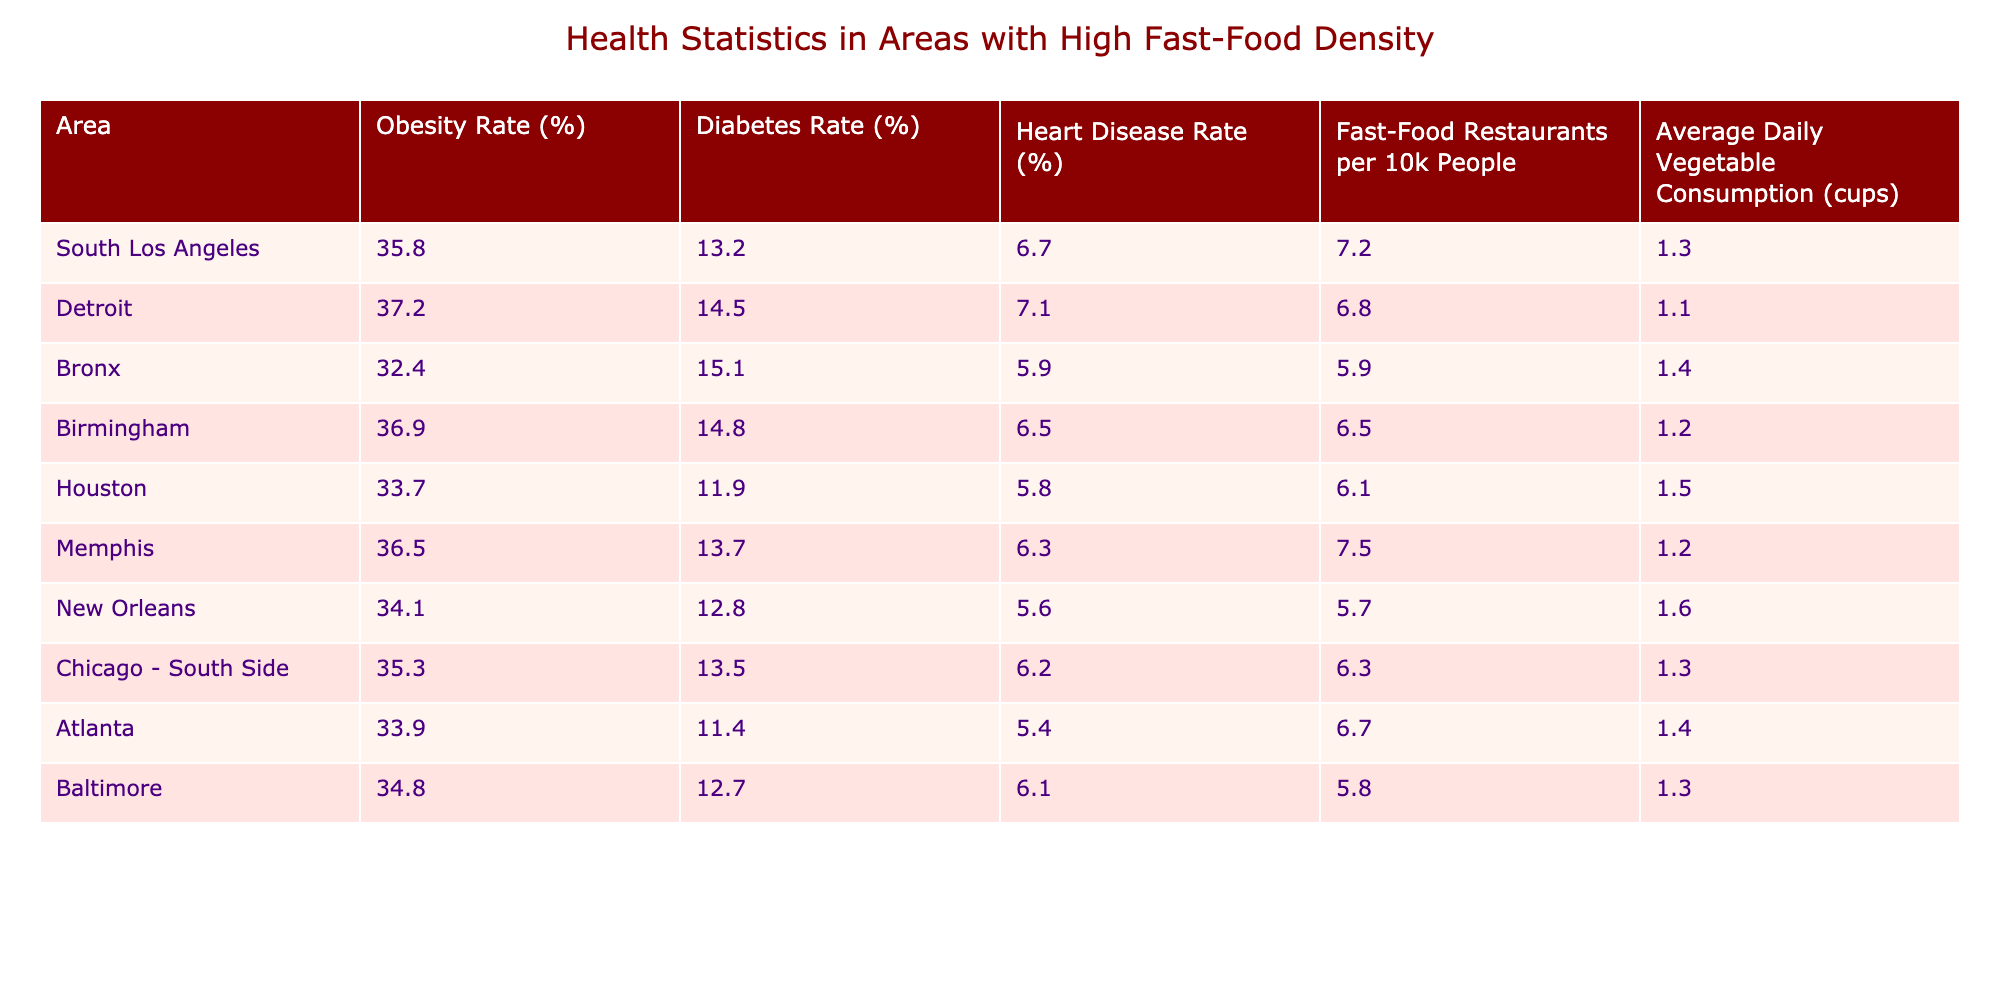What is the obesity rate in Detroit? The table lists Detroit's obesity rate directly under the "Obesity Rate (%)" column, which is 37.2%.
Answer: 37.2% Which area has the highest heart disease rate? By comparing the heart disease rates in each area from the "Heart Disease Rate (%)" column, Detroit has the highest rate at 7.1%.
Answer: Detroit What is the average daily vegetable consumption in New Orleans? The table shows the average daily vegetable consumption in New Orleans under the "Average Daily Vegetable Consumption (cups)" column, which is 1.6 cups.
Answer: 1.6 What is the total number of fast-food restaurants per 10,000 people in South Los Angeles and Chicago - South Side combined? The total is calculated by adding the fast-food restaurant densities: South Los Angeles (7.2) + Chicago - South Side (6.3) = 13.5.
Answer: 13.5 Is the average daily vegetable consumption higher in Houston compared to Detroit? Houston has an average of 1.5 cups, while Detroit has 1.1 cups; thus, the average in Houston is higher.
Answer: Yes Which area has a higher obesity rate: Birmingham or Memphis? Birmingham's obesity rate is 36.9%, while Memphis's is 36.5%. Therefore, Birmingham has a higher rate.
Answer: Birmingham What is the difference in diabetes rate between the Bronx and Atlanta? The difference is calculated by subtracting Atlanta’s diabetes rate (11.4%) from the Bronx’s (15.1%), resulting in 15.1 - 11.4 = 3.7.
Answer: 3.7 Which two areas have the lowest average daily vegetable consumption? The areas with the lowest consumption are Detroit (1.1 cups) and Birmingham (1.2 cups).
Answer: Detroit and Birmingham What percentage of areas listed have an obesity rate above 35%? Out of the 10 areas, 6 have an obesity rate above 35% (South Los Angeles, Detroit, Birmingham, Memphis, Chicago - South Side). Therefore, 6 out of 10 is 60%.
Answer: 60% Is the fast-food restaurant density in New Orleans higher than in Houston? New Orleans has a density of 5.7, and Houston has a density of 6.1. Since 5.7 < 6.1, the density in New Orleans is lower.
Answer: No 